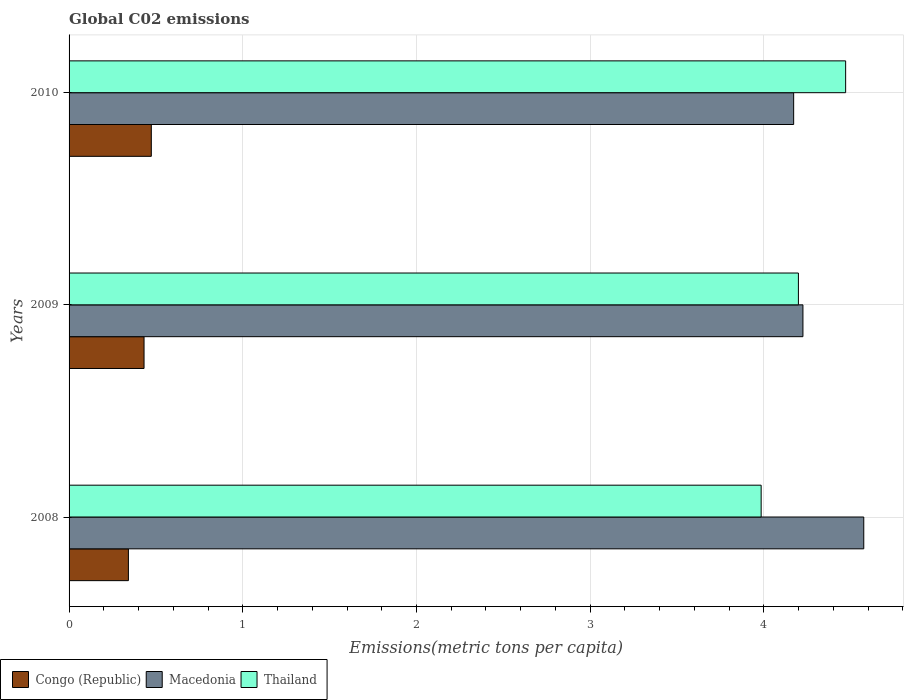How many different coloured bars are there?
Offer a terse response. 3. Are the number of bars per tick equal to the number of legend labels?
Make the answer very short. Yes. How many bars are there on the 1st tick from the bottom?
Your answer should be compact. 3. What is the label of the 3rd group of bars from the top?
Your answer should be very brief. 2008. What is the amount of CO2 emitted in in Macedonia in 2010?
Offer a very short reply. 4.17. Across all years, what is the maximum amount of CO2 emitted in in Macedonia?
Provide a short and direct response. 4.57. Across all years, what is the minimum amount of CO2 emitted in in Macedonia?
Provide a succinct answer. 4.17. In which year was the amount of CO2 emitted in in Macedonia maximum?
Your answer should be very brief. 2008. What is the total amount of CO2 emitted in in Thailand in the graph?
Ensure brevity in your answer.  12.65. What is the difference between the amount of CO2 emitted in in Thailand in 2008 and that in 2009?
Provide a short and direct response. -0.21. What is the difference between the amount of CO2 emitted in in Congo (Republic) in 2010 and the amount of CO2 emitted in in Macedonia in 2009?
Offer a very short reply. -3.75. What is the average amount of CO2 emitted in in Congo (Republic) per year?
Make the answer very short. 0.42. In the year 2008, what is the difference between the amount of CO2 emitted in in Thailand and amount of CO2 emitted in in Congo (Republic)?
Ensure brevity in your answer.  3.64. What is the ratio of the amount of CO2 emitted in in Thailand in 2008 to that in 2009?
Your answer should be very brief. 0.95. Is the difference between the amount of CO2 emitted in in Thailand in 2008 and 2009 greater than the difference between the amount of CO2 emitted in in Congo (Republic) in 2008 and 2009?
Your answer should be compact. No. What is the difference between the highest and the second highest amount of CO2 emitted in in Congo (Republic)?
Offer a terse response. 0.04. What is the difference between the highest and the lowest amount of CO2 emitted in in Congo (Republic)?
Your answer should be very brief. 0.13. Is the sum of the amount of CO2 emitted in in Congo (Republic) in 2008 and 2010 greater than the maximum amount of CO2 emitted in in Thailand across all years?
Provide a succinct answer. No. What does the 2nd bar from the top in 2008 represents?
Make the answer very short. Macedonia. What does the 1st bar from the bottom in 2010 represents?
Your response must be concise. Congo (Republic). Is it the case that in every year, the sum of the amount of CO2 emitted in in Thailand and amount of CO2 emitted in in Congo (Republic) is greater than the amount of CO2 emitted in in Macedonia?
Give a very brief answer. No. How many bars are there?
Offer a very short reply. 9. What is the difference between two consecutive major ticks on the X-axis?
Provide a succinct answer. 1. Does the graph contain grids?
Make the answer very short. Yes. Where does the legend appear in the graph?
Provide a succinct answer. Bottom left. How are the legend labels stacked?
Provide a succinct answer. Horizontal. What is the title of the graph?
Make the answer very short. Global C02 emissions. What is the label or title of the X-axis?
Give a very brief answer. Emissions(metric tons per capita). What is the label or title of the Y-axis?
Give a very brief answer. Years. What is the Emissions(metric tons per capita) in Congo (Republic) in 2008?
Keep it short and to the point. 0.34. What is the Emissions(metric tons per capita) in Macedonia in 2008?
Your response must be concise. 4.57. What is the Emissions(metric tons per capita) in Thailand in 2008?
Your response must be concise. 3.98. What is the Emissions(metric tons per capita) of Congo (Republic) in 2009?
Keep it short and to the point. 0.43. What is the Emissions(metric tons per capita) in Macedonia in 2009?
Give a very brief answer. 4.22. What is the Emissions(metric tons per capita) in Thailand in 2009?
Your answer should be very brief. 4.2. What is the Emissions(metric tons per capita) of Congo (Republic) in 2010?
Your answer should be compact. 0.47. What is the Emissions(metric tons per capita) in Macedonia in 2010?
Make the answer very short. 4.17. What is the Emissions(metric tons per capita) in Thailand in 2010?
Provide a short and direct response. 4.47. Across all years, what is the maximum Emissions(metric tons per capita) of Congo (Republic)?
Your answer should be very brief. 0.47. Across all years, what is the maximum Emissions(metric tons per capita) of Macedonia?
Offer a terse response. 4.57. Across all years, what is the maximum Emissions(metric tons per capita) in Thailand?
Your answer should be compact. 4.47. Across all years, what is the minimum Emissions(metric tons per capita) of Congo (Republic)?
Offer a terse response. 0.34. Across all years, what is the minimum Emissions(metric tons per capita) of Macedonia?
Make the answer very short. 4.17. Across all years, what is the minimum Emissions(metric tons per capita) in Thailand?
Your response must be concise. 3.98. What is the total Emissions(metric tons per capita) of Congo (Republic) in the graph?
Your answer should be very brief. 1.25. What is the total Emissions(metric tons per capita) in Macedonia in the graph?
Your answer should be very brief. 12.97. What is the total Emissions(metric tons per capita) in Thailand in the graph?
Offer a very short reply. 12.65. What is the difference between the Emissions(metric tons per capita) of Congo (Republic) in 2008 and that in 2009?
Make the answer very short. -0.09. What is the difference between the Emissions(metric tons per capita) of Macedonia in 2008 and that in 2009?
Provide a short and direct response. 0.35. What is the difference between the Emissions(metric tons per capita) of Thailand in 2008 and that in 2009?
Your answer should be very brief. -0.21. What is the difference between the Emissions(metric tons per capita) in Congo (Republic) in 2008 and that in 2010?
Offer a very short reply. -0.13. What is the difference between the Emissions(metric tons per capita) in Macedonia in 2008 and that in 2010?
Your answer should be compact. 0.4. What is the difference between the Emissions(metric tons per capita) in Thailand in 2008 and that in 2010?
Your response must be concise. -0.49. What is the difference between the Emissions(metric tons per capita) of Congo (Republic) in 2009 and that in 2010?
Your answer should be very brief. -0.04. What is the difference between the Emissions(metric tons per capita) in Macedonia in 2009 and that in 2010?
Give a very brief answer. 0.05. What is the difference between the Emissions(metric tons per capita) of Thailand in 2009 and that in 2010?
Offer a terse response. -0.27. What is the difference between the Emissions(metric tons per capita) of Congo (Republic) in 2008 and the Emissions(metric tons per capita) of Macedonia in 2009?
Make the answer very short. -3.88. What is the difference between the Emissions(metric tons per capita) in Congo (Republic) in 2008 and the Emissions(metric tons per capita) in Thailand in 2009?
Your answer should be compact. -3.86. What is the difference between the Emissions(metric tons per capita) in Macedonia in 2008 and the Emissions(metric tons per capita) in Thailand in 2009?
Keep it short and to the point. 0.38. What is the difference between the Emissions(metric tons per capita) of Congo (Republic) in 2008 and the Emissions(metric tons per capita) of Macedonia in 2010?
Provide a succinct answer. -3.83. What is the difference between the Emissions(metric tons per capita) in Congo (Republic) in 2008 and the Emissions(metric tons per capita) in Thailand in 2010?
Offer a terse response. -4.13. What is the difference between the Emissions(metric tons per capita) of Macedonia in 2008 and the Emissions(metric tons per capita) of Thailand in 2010?
Keep it short and to the point. 0.1. What is the difference between the Emissions(metric tons per capita) in Congo (Republic) in 2009 and the Emissions(metric tons per capita) in Macedonia in 2010?
Provide a succinct answer. -3.74. What is the difference between the Emissions(metric tons per capita) in Congo (Republic) in 2009 and the Emissions(metric tons per capita) in Thailand in 2010?
Your response must be concise. -4.04. What is the difference between the Emissions(metric tons per capita) in Macedonia in 2009 and the Emissions(metric tons per capita) in Thailand in 2010?
Your answer should be compact. -0.25. What is the average Emissions(metric tons per capita) of Congo (Republic) per year?
Provide a short and direct response. 0.42. What is the average Emissions(metric tons per capita) of Macedonia per year?
Provide a succinct answer. 4.32. What is the average Emissions(metric tons per capita) in Thailand per year?
Provide a succinct answer. 4.22. In the year 2008, what is the difference between the Emissions(metric tons per capita) of Congo (Republic) and Emissions(metric tons per capita) of Macedonia?
Keep it short and to the point. -4.23. In the year 2008, what is the difference between the Emissions(metric tons per capita) in Congo (Republic) and Emissions(metric tons per capita) in Thailand?
Offer a terse response. -3.64. In the year 2008, what is the difference between the Emissions(metric tons per capita) in Macedonia and Emissions(metric tons per capita) in Thailand?
Provide a succinct answer. 0.59. In the year 2009, what is the difference between the Emissions(metric tons per capita) in Congo (Republic) and Emissions(metric tons per capita) in Macedonia?
Make the answer very short. -3.79. In the year 2009, what is the difference between the Emissions(metric tons per capita) of Congo (Republic) and Emissions(metric tons per capita) of Thailand?
Your response must be concise. -3.77. In the year 2009, what is the difference between the Emissions(metric tons per capita) of Macedonia and Emissions(metric tons per capita) of Thailand?
Your answer should be compact. 0.03. In the year 2010, what is the difference between the Emissions(metric tons per capita) of Congo (Republic) and Emissions(metric tons per capita) of Macedonia?
Give a very brief answer. -3.7. In the year 2010, what is the difference between the Emissions(metric tons per capita) of Congo (Republic) and Emissions(metric tons per capita) of Thailand?
Your response must be concise. -4. In the year 2010, what is the difference between the Emissions(metric tons per capita) in Macedonia and Emissions(metric tons per capita) in Thailand?
Your answer should be very brief. -0.3. What is the ratio of the Emissions(metric tons per capita) in Congo (Republic) in 2008 to that in 2009?
Your answer should be compact. 0.79. What is the ratio of the Emissions(metric tons per capita) of Macedonia in 2008 to that in 2009?
Provide a succinct answer. 1.08. What is the ratio of the Emissions(metric tons per capita) of Thailand in 2008 to that in 2009?
Offer a terse response. 0.95. What is the ratio of the Emissions(metric tons per capita) in Congo (Republic) in 2008 to that in 2010?
Your answer should be very brief. 0.72. What is the ratio of the Emissions(metric tons per capita) of Macedonia in 2008 to that in 2010?
Your answer should be compact. 1.1. What is the ratio of the Emissions(metric tons per capita) in Thailand in 2008 to that in 2010?
Keep it short and to the point. 0.89. What is the ratio of the Emissions(metric tons per capita) of Congo (Republic) in 2009 to that in 2010?
Provide a short and direct response. 0.91. What is the ratio of the Emissions(metric tons per capita) in Macedonia in 2009 to that in 2010?
Provide a short and direct response. 1.01. What is the ratio of the Emissions(metric tons per capita) of Thailand in 2009 to that in 2010?
Provide a short and direct response. 0.94. What is the difference between the highest and the second highest Emissions(metric tons per capita) of Congo (Republic)?
Ensure brevity in your answer.  0.04. What is the difference between the highest and the second highest Emissions(metric tons per capita) in Macedonia?
Provide a short and direct response. 0.35. What is the difference between the highest and the second highest Emissions(metric tons per capita) of Thailand?
Keep it short and to the point. 0.27. What is the difference between the highest and the lowest Emissions(metric tons per capita) in Congo (Republic)?
Ensure brevity in your answer.  0.13. What is the difference between the highest and the lowest Emissions(metric tons per capita) of Macedonia?
Offer a very short reply. 0.4. What is the difference between the highest and the lowest Emissions(metric tons per capita) in Thailand?
Give a very brief answer. 0.49. 